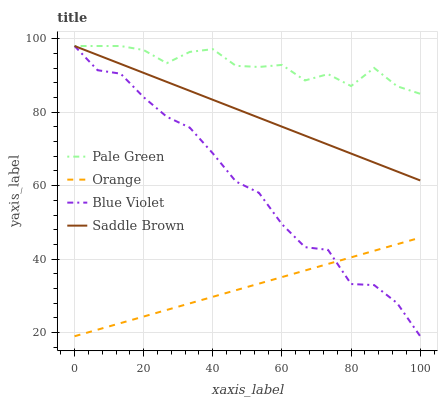Does Orange have the minimum area under the curve?
Answer yes or no. Yes. Does Pale Green have the maximum area under the curve?
Answer yes or no. Yes. Does Saddle Brown have the minimum area under the curve?
Answer yes or no. No. Does Saddle Brown have the maximum area under the curve?
Answer yes or no. No. Is Saddle Brown the smoothest?
Answer yes or no. Yes. Is Blue Violet the roughest?
Answer yes or no. Yes. Is Pale Green the smoothest?
Answer yes or no. No. Is Pale Green the roughest?
Answer yes or no. No. Does Saddle Brown have the lowest value?
Answer yes or no. No. Does Blue Violet have the highest value?
Answer yes or no. Yes. Is Orange less than Pale Green?
Answer yes or no. Yes. Is Saddle Brown greater than Orange?
Answer yes or no. Yes. Does Saddle Brown intersect Blue Violet?
Answer yes or no. Yes. Is Saddle Brown less than Blue Violet?
Answer yes or no. No. Is Saddle Brown greater than Blue Violet?
Answer yes or no. No. Does Orange intersect Pale Green?
Answer yes or no. No. 